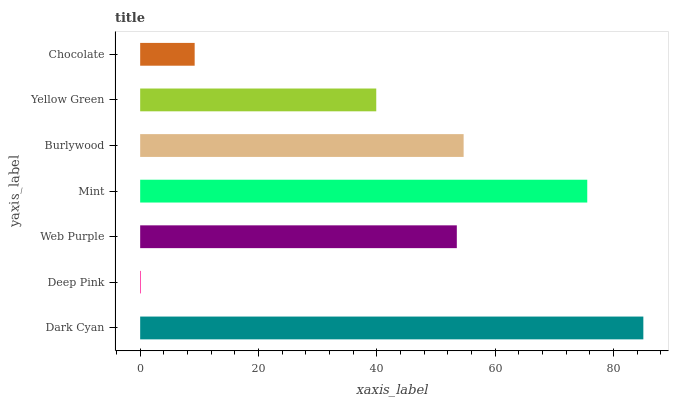Is Deep Pink the minimum?
Answer yes or no. Yes. Is Dark Cyan the maximum?
Answer yes or no. Yes. Is Web Purple the minimum?
Answer yes or no. No. Is Web Purple the maximum?
Answer yes or no. No. Is Web Purple greater than Deep Pink?
Answer yes or no. Yes. Is Deep Pink less than Web Purple?
Answer yes or no. Yes. Is Deep Pink greater than Web Purple?
Answer yes or no. No. Is Web Purple less than Deep Pink?
Answer yes or no. No. Is Web Purple the high median?
Answer yes or no. Yes. Is Web Purple the low median?
Answer yes or no. Yes. Is Burlywood the high median?
Answer yes or no. No. Is Deep Pink the low median?
Answer yes or no. No. 